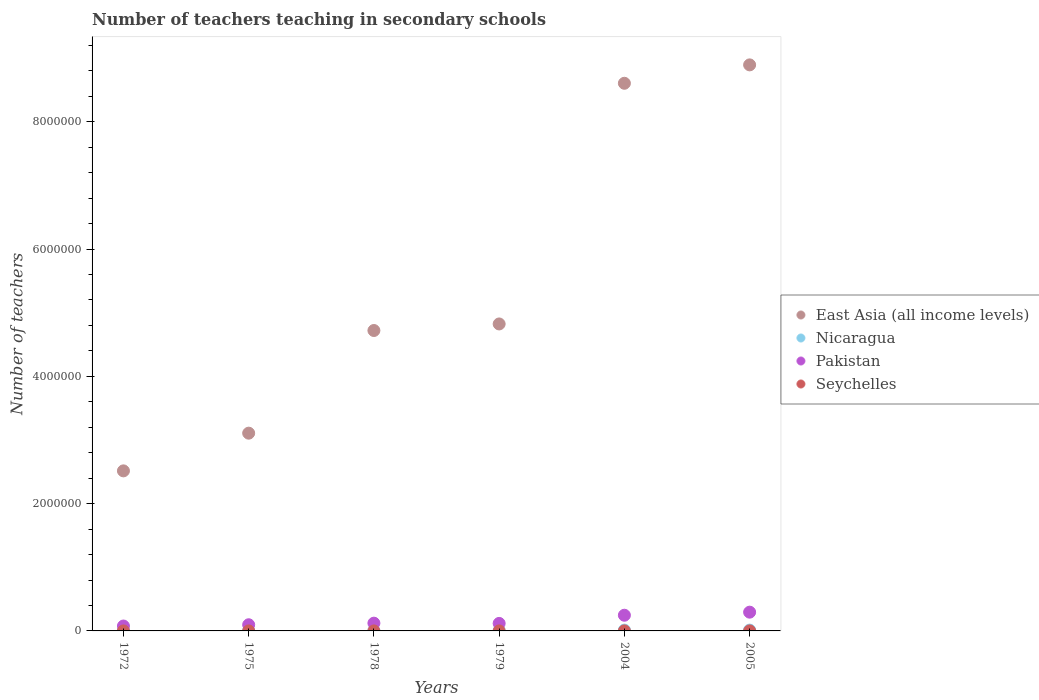How many different coloured dotlines are there?
Your response must be concise. 4. What is the number of teachers teaching in secondary schools in Seychelles in 1975?
Your answer should be compact. 177. Across all years, what is the maximum number of teachers teaching in secondary schools in East Asia (all income levels)?
Your answer should be compact. 8.89e+06. Across all years, what is the minimum number of teachers teaching in secondary schools in Seychelles?
Your answer should be very brief. 140. In which year was the number of teachers teaching in secondary schools in Nicaragua maximum?
Make the answer very short. 2005. In which year was the number of teachers teaching in secondary schools in Seychelles minimum?
Give a very brief answer. 1972. What is the total number of teachers teaching in secondary schools in East Asia (all income levels) in the graph?
Offer a terse response. 3.27e+07. What is the difference between the number of teachers teaching in secondary schools in East Asia (all income levels) in 1972 and that in 1978?
Your answer should be compact. -2.21e+06. What is the difference between the number of teachers teaching in secondary schools in Nicaragua in 1979 and the number of teachers teaching in secondary schools in East Asia (all income levels) in 1972?
Make the answer very short. -2.51e+06. What is the average number of teachers teaching in secondary schools in Nicaragua per year?
Provide a succinct answer. 6049.83. In the year 1978, what is the difference between the number of teachers teaching in secondary schools in Nicaragua and number of teachers teaching in secondary schools in Pakistan?
Offer a very short reply. -1.19e+05. In how many years, is the number of teachers teaching in secondary schools in Seychelles greater than 7200000?
Your answer should be very brief. 0. What is the ratio of the number of teachers teaching in secondary schools in Nicaragua in 1979 to that in 2004?
Provide a succinct answer. 0.28. Is the difference between the number of teachers teaching in secondary schools in Nicaragua in 1975 and 2005 greater than the difference between the number of teachers teaching in secondary schools in Pakistan in 1975 and 2005?
Your answer should be compact. Yes. What is the difference between the highest and the second highest number of teachers teaching in secondary schools in Pakistan?
Offer a terse response. 4.81e+04. What is the difference between the highest and the lowest number of teachers teaching in secondary schools in Nicaragua?
Make the answer very short. 1.11e+04. In how many years, is the number of teachers teaching in secondary schools in Pakistan greater than the average number of teachers teaching in secondary schools in Pakistan taken over all years?
Your answer should be compact. 2. Is the sum of the number of teachers teaching in secondary schools in Pakistan in 1975 and 2005 greater than the maximum number of teachers teaching in secondary schools in Seychelles across all years?
Keep it short and to the point. Yes. Is it the case that in every year, the sum of the number of teachers teaching in secondary schools in Nicaragua and number of teachers teaching in secondary schools in East Asia (all income levels)  is greater than the sum of number of teachers teaching in secondary schools in Pakistan and number of teachers teaching in secondary schools in Seychelles?
Ensure brevity in your answer.  Yes. How many years are there in the graph?
Offer a terse response. 6. What is the difference between two consecutive major ticks on the Y-axis?
Give a very brief answer. 2.00e+06. Are the values on the major ticks of Y-axis written in scientific E-notation?
Your answer should be compact. No. Does the graph contain any zero values?
Your answer should be compact. No. Where does the legend appear in the graph?
Offer a very short reply. Center right. How many legend labels are there?
Provide a short and direct response. 4. How are the legend labels stacked?
Give a very brief answer. Vertical. What is the title of the graph?
Your answer should be compact. Number of teachers teaching in secondary schools. What is the label or title of the Y-axis?
Offer a very short reply. Number of teachers. What is the Number of teachers in East Asia (all income levels) in 1972?
Provide a succinct answer. 2.52e+06. What is the Number of teachers of Nicaragua in 1972?
Give a very brief answer. 1916. What is the Number of teachers in Pakistan in 1972?
Keep it short and to the point. 7.69e+04. What is the Number of teachers in Seychelles in 1972?
Offer a very short reply. 140. What is the Number of teachers in East Asia (all income levels) in 1975?
Your answer should be very brief. 3.11e+06. What is the Number of teachers in Nicaragua in 1975?
Your answer should be very brief. 2308. What is the Number of teachers of Pakistan in 1975?
Your answer should be compact. 9.69e+04. What is the Number of teachers in Seychelles in 1975?
Your answer should be compact. 177. What is the Number of teachers of East Asia (all income levels) in 1978?
Provide a succinct answer. 4.72e+06. What is the Number of teachers of Nicaragua in 1978?
Ensure brevity in your answer.  2720. What is the Number of teachers in Pakistan in 1978?
Provide a succinct answer. 1.22e+05. What is the Number of teachers in Seychelles in 1978?
Keep it short and to the point. 242. What is the Number of teachers of East Asia (all income levels) in 1979?
Offer a terse response. 4.82e+06. What is the Number of teachers of Nicaragua in 1979?
Your answer should be compact. 3532. What is the Number of teachers of Pakistan in 1979?
Give a very brief answer. 1.18e+05. What is the Number of teachers of Seychelles in 1979?
Your answer should be very brief. 288. What is the Number of teachers of East Asia (all income levels) in 2004?
Your answer should be compact. 8.61e+06. What is the Number of teachers in Nicaragua in 2004?
Your answer should be very brief. 1.28e+04. What is the Number of teachers in Pakistan in 2004?
Make the answer very short. 2.47e+05. What is the Number of teachers of Seychelles in 2004?
Your response must be concise. 590. What is the Number of teachers of East Asia (all income levels) in 2005?
Provide a succinct answer. 8.89e+06. What is the Number of teachers of Nicaragua in 2005?
Make the answer very short. 1.30e+04. What is the Number of teachers of Pakistan in 2005?
Offer a very short reply. 2.95e+05. What is the Number of teachers in Seychelles in 2005?
Keep it short and to the point. 589. Across all years, what is the maximum Number of teachers of East Asia (all income levels)?
Offer a very short reply. 8.89e+06. Across all years, what is the maximum Number of teachers in Nicaragua?
Provide a short and direct response. 1.30e+04. Across all years, what is the maximum Number of teachers of Pakistan?
Keep it short and to the point. 2.95e+05. Across all years, what is the maximum Number of teachers in Seychelles?
Give a very brief answer. 590. Across all years, what is the minimum Number of teachers in East Asia (all income levels)?
Offer a very short reply. 2.52e+06. Across all years, what is the minimum Number of teachers of Nicaragua?
Ensure brevity in your answer.  1916. Across all years, what is the minimum Number of teachers in Pakistan?
Your answer should be very brief. 7.69e+04. Across all years, what is the minimum Number of teachers of Seychelles?
Your answer should be compact. 140. What is the total Number of teachers of East Asia (all income levels) in the graph?
Give a very brief answer. 3.27e+07. What is the total Number of teachers in Nicaragua in the graph?
Your response must be concise. 3.63e+04. What is the total Number of teachers in Pakistan in the graph?
Offer a very short reply. 9.55e+05. What is the total Number of teachers in Seychelles in the graph?
Your answer should be compact. 2026. What is the difference between the Number of teachers of East Asia (all income levels) in 1972 and that in 1975?
Provide a short and direct response. -5.92e+05. What is the difference between the Number of teachers of Nicaragua in 1972 and that in 1975?
Your answer should be very brief. -392. What is the difference between the Number of teachers in Pakistan in 1972 and that in 1975?
Provide a succinct answer. -2.00e+04. What is the difference between the Number of teachers of Seychelles in 1972 and that in 1975?
Offer a very short reply. -37. What is the difference between the Number of teachers of East Asia (all income levels) in 1972 and that in 1978?
Keep it short and to the point. -2.21e+06. What is the difference between the Number of teachers of Nicaragua in 1972 and that in 1978?
Keep it short and to the point. -804. What is the difference between the Number of teachers in Pakistan in 1972 and that in 1978?
Provide a short and direct response. -4.51e+04. What is the difference between the Number of teachers of Seychelles in 1972 and that in 1978?
Give a very brief answer. -102. What is the difference between the Number of teachers of East Asia (all income levels) in 1972 and that in 1979?
Your answer should be very brief. -2.31e+06. What is the difference between the Number of teachers in Nicaragua in 1972 and that in 1979?
Provide a succinct answer. -1616. What is the difference between the Number of teachers of Pakistan in 1972 and that in 1979?
Provide a short and direct response. -4.12e+04. What is the difference between the Number of teachers in Seychelles in 1972 and that in 1979?
Offer a terse response. -148. What is the difference between the Number of teachers in East Asia (all income levels) in 1972 and that in 2004?
Your response must be concise. -6.09e+06. What is the difference between the Number of teachers of Nicaragua in 1972 and that in 2004?
Keep it short and to the point. -1.09e+04. What is the difference between the Number of teachers in Pakistan in 1972 and that in 2004?
Provide a succinct answer. -1.70e+05. What is the difference between the Number of teachers in Seychelles in 1972 and that in 2004?
Give a very brief answer. -450. What is the difference between the Number of teachers in East Asia (all income levels) in 1972 and that in 2005?
Provide a short and direct response. -6.38e+06. What is the difference between the Number of teachers in Nicaragua in 1972 and that in 2005?
Give a very brief answer. -1.11e+04. What is the difference between the Number of teachers in Pakistan in 1972 and that in 2005?
Make the answer very short. -2.18e+05. What is the difference between the Number of teachers of Seychelles in 1972 and that in 2005?
Give a very brief answer. -449. What is the difference between the Number of teachers of East Asia (all income levels) in 1975 and that in 1978?
Keep it short and to the point. -1.61e+06. What is the difference between the Number of teachers in Nicaragua in 1975 and that in 1978?
Give a very brief answer. -412. What is the difference between the Number of teachers of Pakistan in 1975 and that in 1978?
Your answer should be compact. -2.50e+04. What is the difference between the Number of teachers of Seychelles in 1975 and that in 1978?
Provide a succinct answer. -65. What is the difference between the Number of teachers in East Asia (all income levels) in 1975 and that in 1979?
Your response must be concise. -1.72e+06. What is the difference between the Number of teachers in Nicaragua in 1975 and that in 1979?
Offer a very short reply. -1224. What is the difference between the Number of teachers in Pakistan in 1975 and that in 1979?
Your response must be concise. -2.11e+04. What is the difference between the Number of teachers of Seychelles in 1975 and that in 1979?
Ensure brevity in your answer.  -111. What is the difference between the Number of teachers of East Asia (all income levels) in 1975 and that in 2004?
Offer a terse response. -5.50e+06. What is the difference between the Number of teachers in Nicaragua in 1975 and that in 2004?
Offer a terse response. -1.05e+04. What is the difference between the Number of teachers in Pakistan in 1975 and that in 2004?
Offer a very short reply. -1.50e+05. What is the difference between the Number of teachers of Seychelles in 1975 and that in 2004?
Provide a short and direct response. -413. What is the difference between the Number of teachers in East Asia (all income levels) in 1975 and that in 2005?
Your answer should be compact. -5.79e+06. What is the difference between the Number of teachers in Nicaragua in 1975 and that in 2005?
Your answer should be very brief. -1.07e+04. What is the difference between the Number of teachers of Pakistan in 1975 and that in 2005?
Your answer should be compact. -1.98e+05. What is the difference between the Number of teachers of Seychelles in 1975 and that in 2005?
Keep it short and to the point. -412. What is the difference between the Number of teachers in East Asia (all income levels) in 1978 and that in 1979?
Offer a terse response. -1.03e+05. What is the difference between the Number of teachers in Nicaragua in 1978 and that in 1979?
Offer a very short reply. -812. What is the difference between the Number of teachers in Pakistan in 1978 and that in 1979?
Offer a terse response. 3885. What is the difference between the Number of teachers in Seychelles in 1978 and that in 1979?
Offer a very short reply. -46. What is the difference between the Number of teachers of East Asia (all income levels) in 1978 and that in 2004?
Offer a very short reply. -3.88e+06. What is the difference between the Number of teachers of Nicaragua in 1978 and that in 2004?
Your answer should be very brief. -1.01e+04. What is the difference between the Number of teachers of Pakistan in 1978 and that in 2004?
Your response must be concise. -1.25e+05. What is the difference between the Number of teachers in Seychelles in 1978 and that in 2004?
Keep it short and to the point. -348. What is the difference between the Number of teachers in East Asia (all income levels) in 1978 and that in 2005?
Make the answer very short. -4.17e+06. What is the difference between the Number of teachers in Nicaragua in 1978 and that in 2005?
Offer a terse response. -1.03e+04. What is the difference between the Number of teachers of Pakistan in 1978 and that in 2005?
Make the answer very short. -1.73e+05. What is the difference between the Number of teachers in Seychelles in 1978 and that in 2005?
Give a very brief answer. -347. What is the difference between the Number of teachers in East Asia (all income levels) in 1979 and that in 2004?
Your response must be concise. -3.78e+06. What is the difference between the Number of teachers of Nicaragua in 1979 and that in 2004?
Your answer should be compact. -9311. What is the difference between the Number of teachers in Pakistan in 1979 and that in 2004?
Your response must be concise. -1.28e+05. What is the difference between the Number of teachers in Seychelles in 1979 and that in 2004?
Offer a very short reply. -302. What is the difference between the Number of teachers of East Asia (all income levels) in 1979 and that in 2005?
Give a very brief answer. -4.07e+06. What is the difference between the Number of teachers in Nicaragua in 1979 and that in 2005?
Provide a succinct answer. -9448. What is the difference between the Number of teachers in Pakistan in 1979 and that in 2005?
Keep it short and to the point. -1.77e+05. What is the difference between the Number of teachers in Seychelles in 1979 and that in 2005?
Give a very brief answer. -301. What is the difference between the Number of teachers in East Asia (all income levels) in 2004 and that in 2005?
Provide a short and direct response. -2.89e+05. What is the difference between the Number of teachers of Nicaragua in 2004 and that in 2005?
Your answer should be compact. -137. What is the difference between the Number of teachers of Pakistan in 2004 and that in 2005?
Your response must be concise. -4.81e+04. What is the difference between the Number of teachers of Seychelles in 2004 and that in 2005?
Offer a terse response. 1. What is the difference between the Number of teachers in East Asia (all income levels) in 1972 and the Number of teachers in Nicaragua in 1975?
Provide a short and direct response. 2.51e+06. What is the difference between the Number of teachers in East Asia (all income levels) in 1972 and the Number of teachers in Pakistan in 1975?
Ensure brevity in your answer.  2.42e+06. What is the difference between the Number of teachers of East Asia (all income levels) in 1972 and the Number of teachers of Seychelles in 1975?
Your answer should be compact. 2.51e+06. What is the difference between the Number of teachers of Nicaragua in 1972 and the Number of teachers of Pakistan in 1975?
Offer a very short reply. -9.50e+04. What is the difference between the Number of teachers of Nicaragua in 1972 and the Number of teachers of Seychelles in 1975?
Offer a terse response. 1739. What is the difference between the Number of teachers in Pakistan in 1972 and the Number of teachers in Seychelles in 1975?
Your answer should be very brief. 7.67e+04. What is the difference between the Number of teachers of East Asia (all income levels) in 1972 and the Number of teachers of Nicaragua in 1978?
Your answer should be compact. 2.51e+06. What is the difference between the Number of teachers of East Asia (all income levels) in 1972 and the Number of teachers of Pakistan in 1978?
Provide a short and direct response. 2.39e+06. What is the difference between the Number of teachers of East Asia (all income levels) in 1972 and the Number of teachers of Seychelles in 1978?
Provide a succinct answer. 2.51e+06. What is the difference between the Number of teachers in Nicaragua in 1972 and the Number of teachers in Pakistan in 1978?
Offer a terse response. -1.20e+05. What is the difference between the Number of teachers of Nicaragua in 1972 and the Number of teachers of Seychelles in 1978?
Provide a succinct answer. 1674. What is the difference between the Number of teachers in Pakistan in 1972 and the Number of teachers in Seychelles in 1978?
Keep it short and to the point. 7.67e+04. What is the difference between the Number of teachers in East Asia (all income levels) in 1972 and the Number of teachers in Nicaragua in 1979?
Make the answer very short. 2.51e+06. What is the difference between the Number of teachers in East Asia (all income levels) in 1972 and the Number of teachers in Pakistan in 1979?
Ensure brevity in your answer.  2.40e+06. What is the difference between the Number of teachers of East Asia (all income levels) in 1972 and the Number of teachers of Seychelles in 1979?
Make the answer very short. 2.51e+06. What is the difference between the Number of teachers in Nicaragua in 1972 and the Number of teachers in Pakistan in 1979?
Your answer should be very brief. -1.16e+05. What is the difference between the Number of teachers of Nicaragua in 1972 and the Number of teachers of Seychelles in 1979?
Offer a very short reply. 1628. What is the difference between the Number of teachers in Pakistan in 1972 and the Number of teachers in Seychelles in 1979?
Provide a succinct answer. 7.66e+04. What is the difference between the Number of teachers of East Asia (all income levels) in 1972 and the Number of teachers of Nicaragua in 2004?
Your answer should be compact. 2.50e+06. What is the difference between the Number of teachers of East Asia (all income levels) in 1972 and the Number of teachers of Pakistan in 2004?
Your response must be concise. 2.27e+06. What is the difference between the Number of teachers in East Asia (all income levels) in 1972 and the Number of teachers in Seychelles in 2004?
Make the answer very short. 2.51e+06. What is the difference between the Number of teachers in Nicaragua in 1972 and the Number of teachers in Pakistan in 2004?
Offer a terse response. -2.45e+05. What is the difference between the Number of teachers of Nicaragua in 1972 and the Number of teachers of Seychelles in 2004?
Offer a very short reply. 1326. What is the difference between the Number of teachers of Pakistan in 1972 and the Number of teachers of Seychelles in 2004?
Your response must be concise. 7.63e+04. What is the difference between the Number of teachers of East Asia (all income levels) in 1972 and the Number of teachers of Nicaragua in 2005?
Provide a short and direct response. 2.50e+06. What is the difference between the Number of teachers in East Asia (all income levels) in 1972 and the Number of teachers in Pakistan in 2005?
Offer a terse response. 2.22e+06. What is the difference between the Number of teachers of East Asia (all income levels) in 1972 and the Number of teachers of Seychelles in 2005?
Your answer should be very brief. 2.51e+06. What is the difference between the Number of teachers in Nicaragua in 1972 and the Number of teachers in Pakistan in 2005?
Keep it short and to the point. -2.93e+05. What is the difference between the Number of teachers of Nicaragua in 1972 and the Number of teachers of Seychelles in 2005?
Your answer should be compact. 1327. What is the difference between the Number of teachers of Pakistan in 1972 and the Number of teachers of Seychelles in 2005?
Provide a short and direct response. 7.63e+04. What is the difference between the Number of teachers in East Asia (all income levels) in 1975 and the Number of teachers in Nicaragua in 1978?
Offer a very short reply. 3.10e+06. What is the difference between the Number of teachers of East Asia (all income levels) in 1975 and the Number of teachers of Pakistan in 1978?
Provide a short and direct response. 2.99e+06. What is the difference between the Number of teachers in East Asia (all income levels) in 1975 and the Number of teachers in Seychelles in 1978?
Give a very brief answer. 3.11e+06. What is the difference between the Number of teachers in Nicaragua in 1975 and the Number of teachers in Pakistan in 1978?
Offer a very short reply. -1.20e+05. What is the difference between the Number of teachers of Nicaragua in 1975 and the Number of teachers of Seychelles in 1978?
Your response must be concise. 2066. What is the difference between the Number of teachers of Pakistan in 1975 and the Number of teachers of Seychelles in 1978?
Keep it short and to the point. 9.67e+04. What is the difference between the Number of teachers of East Asia (all income levels) in 1975 and the Number of teachers of Nicaragua in 1979?
Offer a very short reply. 3.10e+06. What is the difference between the Number of teachers of East Asia (all income levels) in 1975 and the Number of teachers of Pakistan in 1979?
Offer a very short reply. 2.99e+06. What is the difference between the Number of teachers of East Asia (all income levels) in 1975 and the Number of teachers of Seychelles in 1979?
Your answer should be compact. 3.11e+06. What is the difference between the Number of teachers in Nicaragua in 1975 and the Number of teachers in Pakistan in 1979?
Ensure brevity in your answer.  -1.16e+05. What is the difference between the Number of teachers in Nicaragua in 1975 and the Number of teachers in Seychelles in 1979?
Offer a very short reply. 2020. What is the difference between the Number of teachers of Pakistan in 1975 and the Number of teachers of Seychelles in 1979?
Provide a succinct answer. 9.67e+04. What is the difference between the Number of teachers in East Asia (all income levels) in 1975 and the Number of teachers in Nicaragua in 2004?
Keep it short and to the point. 3.09e+06. What is the difference between the Number of teachers in East Asia (all income levels) in 1975 and the Number of teachers in Pakistan in 2004?
Give a very brief answer. 2.86e+06. What is the difference between the Number of teachers in East Asia (all income levels) in 1975 and the Number of teachers in Seychelles in 2004?
Make the answer very short. 3.11e+06. What is the difference between the Number of teachers in Nicaragua in 1975 and the Number of teachers in Pakistan in 2004?
Provide a short and direct response. -2.44e+05. What is the difference between the Number of teachers in Nicaragua in 1975 and the Number of teachers in Seychelles in 2004?
Make the answer very short. 1718. What is the difference between the Number of teachers in Pakistan in 1975 and the Number of teachers in Seychelles in 2004?
Ensure brevity in your answer.  9.64e+04. What is the difference between the Number of teachers in East Asia (all income levels) in 1975 and the Number of teachers in Nicaragua in 2005?
Provide a succinct answer. 3.09e+06. What is the difference between the Number of teachers of East Asia (all income levels) in 1975 and the Number of teachers of Pakistan in 2005?
Offer a terse response. 2.81e+06. What is the difference between the Number of teachers in East Asia (all income levels) in 1975 and the Number of teachers in Seychelles in 2005?
Your answer should be compact. 3.11e+06. What is the difference between the Number of teachers of Nicaragua in 1975 and the Number of teachers of Pakistan in 2005?
Give a very brief answer. -2.92e+05. What is the difference between the Number of teachers of Nicaragua in 1975 and the Number of teachers of Seychelles in 2005?
Make the answer very short. 1719. What is the difference between the Number of teachers of Pakistan in 1975 and the Number of teachers of Seychelles in 2005?
Ensure brevity in your answer.  9.64e+04. What is the difference between the Number of teachers in East Asia (all income levels) in 1978 and the Number of teachers in Nicaragua in 1979?
Offer a very short reply. 4.72e+06. What is the difference between the Number of teachers in East Asia (all income levels) in 1978 and the Number of teachers in Pakistan in 1979?
Your answer should be compact. 4.60e+06. What is the difference between the Number of teachers in East Asia (all income levels) in 1978 and the Number of teachers in Seychelles in 1979?
Provide a succinct answer. 4.72e+06. What is the difference between the Number of teachers in Nicaragua in 1978 and the Number of teachers in Pakistan in 1979?
Give a very brief answer. -1.15e+05. What is the difference between the Number of teachers of Nicaragua in 1978 and the Number of teachers of Seychelles in 1979?
Provide a short and direct response. 2432. What is the difference between the Number of teachers of Pakistan in 1978 and the Number of teachers of Seychelles in 1979?
Provide a short and direct response. 1.22e+05. What is the difference between the Number of teachers in East Asia (all income levels) in 1978 and the Number of teachers in Nicaragua in 2004?
Make the answer very short. 4.71e+06. What is the difference between the Number of teachers in East Asia (all income levels) in 1978 and the Number of teachers in Pakistan in 2004?
Offer a terse response. 4.47e+06. What is the difference between the Number of teachers in East Asia (all income levels) in 1978 and the Number of teachers in Seychelles in 2004?
Make the answer very short. 4.72e+06. What is the difference between the Number of teachers in Nicaragua in 1978 and the Number of teachers in Pakistan in 2004?
Provide a short and direct response. -2.44e+05. What is the difference between the Number of teachers of Nicaragua in 1978 and the Number of teachers of Seychelles in 2004?
Ensure brevity in your answer.  2130. What is the difference between the Number of teachers in Pakistan in 1978 and the Number of teachers in Seychelles in 2004?
Make the answer very short. 1.21e+05. What is the difference between the Number of teachers of East Asia (all income levels) in 1978 and the Number of teachers of Nicaragua in 2005?
Your answer should be very brief. 4.71e+06. What is the difference between the Number of teachers in East Asia (all income levels) in 1978 and the Number of teachers in Pakistan in 2005?
Your answer should be very brief. 4.43e+06. What is the difference between the Number of teachers of East Asia (all income levels) in 1978 and the Number of teachers of Seychelles in 2005?
Offer a terse response. 4.72e+06. What is the difference between the Number of teachers in Nicaragua in 1978 and the Number of teachers in Pakistan in 2005?
Offer a terse response. -2.92e+05. What is the difference between the Number of teachers in Nicaragua in 1978 and the Number of teachers in Seychelles in 2005?
Make the answer very short. 2131. What is the difference between the Number of teachers in Pakistan in 1978 and the Number of teachers in Seychelles in 2005?
Provide a short and direct response. 1.21e+05. What is the difference between the Number of teachers in East Asia (all income levels) in 1979 and the Number of teachers in Nicaragua in 2004?
Ensure brevity in your answer.  4.81e+06. What is the difference between the Number of teachers in East Asia (all income levels) in 1979 and the Number of teachers in Pakistan in 2004?
Ensure brevity in your answer.  4.58e+06. What is the difference between the Number of teachers in East Asia (all income levels) in 1979 and the Number of teachers in Seychelles in 2004?
Ensure brevity in your answer.  4.82e+06. What is the difference between the Number of teachers of Nicaragua in 1979 and the Number of teachers of Pakistan in 2004?
Give a very brief answer. -2.43e+05. What is the difference between the Number of teachers in Nicaragua in 1979 and the Number of teachers in Seychelles in 2004?
Ensure brevity in your answer.  2942. What is the difference between the Number of teachers of Pakistan in 1979 and the Number of teachers of Seychelles in 2004?
Provide a succinct answer. 1.17e+05. What is the difference between the Number of teachers of East Asia (all income levels) in 1979 and the Number of teachers of Nicaragua in 2005?
Offer a very short reply. 4.81e+06. What is the difference between the Number of teachers in East Asia (all income levels) in 1979 and the Number of teachers in Pakistan in 2005?
Keep it short and to the point. 4.53e+06. What is the difference between the Number of teachers of East Asia (all income levels) in 1979 and the Number of teachers of Seychelles in 2005?
Your response must be concise. 4.82e+06. What is the difference between the Number of teachers of Nicaragua in 1979 and the Number of teachers of Pakistan in 2005?
Your answer should be very brief. -2.91e+05. What is the difference between the Number of teachers in Nicaragua in 1979 and the Number of teachers in Seychelles in 2005?
Keep it short and to the point. 2943. What is the difference between the Number of teachers in Pakistan in 1979 and the Number of teachers in Seychelles in 2005?
Offer a terse response. 1.17e+05. What is the difference between the Number of teachers of East Asia (all income levels) in 2004 and the Number of teachers of Nicaragua in 2005?
Your answer should be very brief. 8.59e+06. What is the difference between the Number of teachers in East Asia (all income levels) in 2004 and the Number of teachers in Pakistan in 2005?
Offer a very short reply. 8.31e+06. What is the difference between the Number of teachers of East Asia (all income levels) in 2004 and the Number of teachers of Seychelles in 2005?
Provide a short and direct response. 8.60e+06. What is the difference between the Number of teachers in Nicaragua in 2004 and the Number of teachers in Pakistan in 2005?
Your response must be concise. -2.82e+05. What is the difference between the Number of teachers in Nicaragua in 2004 and the Number of teachers in Seychelles in 2005?
Provide a short and direct response. 1.23e+04. What is the difference between the Number of teachers of Pakistan in 2004 and the Number of teachers of Seychelles in 2005?
Keep it short and to the point. 2.46e+05. What is the average Number of teachers of East Asia (all income levels) per year?
Offer a very short reply. 5.44e+06. What is the average Number of teachers in Nicaragua per year?
Give a very brief answer. 6049.83. What is the average Number of teachers of Pakistan per year?
Offer a terse response. 1.59e+05. What is the average Number of teachers in Seychelles per year?
Provide a succinct answer. 337.67. In the year 1972, what is the difference between the Number of teachers of East Asia (all income levels) and Number of teachers of Nicaragua?
Keep it short and to the point. 2.51e+06. In the year 1972, what is the difference between the Number of teachers in East Asia (all income levels) and Number of teachers in Pakistan?
Offer a very short reply. 2.44e+06. In the year 1972, what is the difference between the Number of teachers in East Asia (all income levels) and Number of teachers in Seychelles?
Provide a succinct answer. 2.51e+06. In the year 1972, what is the difference between the Number of teachers of Nicaragua and Number of teachers of Pakistan?
Offer a terse response. -7.50e+04. In the year 1972, what is the difference between the Number of teachers in Nicaragua and Number of teachers in Seychelles?
Provide a short and direct response. 1776. In the year 1972, what is the difference between the Number of teachers of Pakistan and Number of teachers of Seychelles?
Give a very brief answer. 7.68e+04. In the year 1975, what is the difference between the Number of teachers in East Asia (all income levels) and Number of teachers in Nicaragua?
Ensure brevity in your answer.  3.11e+06. In the year 1975, what is the difference between the Number of teachers of East Asia (all income levels) and Number of teachers of Pakistan?
Ensure brevity in your answer.  3.01e+06. In the year 1975, what is the difference between the Number of teachers in East Asia (all income levels) and Number of teachers in Seychelles?
Give a very brief answer. 3.11e+06. In the year 1975, what is the difference between the Number of teachers in Nicaragua and Number of teachers in Pakistan?
Offer a very short reply. -9.46e+04. In the year 1975, what is the difference between the Number of teachers in Nicaragua and Number of teachers in Seychelles?
Your answer should be compact. 2131. In the year 1975, what is the difference between the Number of teachers of Pakistan and Number of teachers of Seychelles?
Make the answer very short. 9.68e+04. In the year 1978, what is the difference between the Number of teachers of East Asia (all income levels) and Number of teachers of Nicaragua?
Keep it short and to the point. 4.72e+06. In the year 1978, what is the difference between the Number of teachers in East Asia (all income levels) and Number of teachers in Pakistan?
Give a very brief answer. 4.60e+06. In the year 1978, what is the difference between the Number of teachers in East Asia (all income levels) and Number of teachers in Seychelles?
Offer a very short reply. 4.72e+06. In the year 1978, what is the difference between the Number of teachers in Nicaragua and Number of teachers in Pakistan?
Your answer should be compact. -1.19e+05. In the year 1978, what is the difference between the Number of teachers of Nicaragua and Number of teachers of Seychelles?
Offer a terse response. 2478. In the year 1978, what is the difference between the Number of teachers in Pakistan and Number of teachers in Seychelles?
Keep it short and to the point. 1.22e+05. In the year 1979, what is the difference between the Number of teachers in East Asia (all income levels) and Number of teachers in Nicaragua?
Offer a very short reply. 4.82e+06. In the year 1979, what is the difference between the Number of teachers of East Asia (all income levels) and Number of teachers of Pakistan?
Offer a very short reply. 4.71e+06. In the year 1979, what is the difference between the Number of teachers of East Asia (all income levels) and Number of teachers of Seychelles?
Offer a very short reply. 4.82e+06. In the year 1979, what is the difference between the Number of teachers in Nicaragua and Number of teachers in Pakistan?
Make the answer very short. -1.15e+05. In the year 1979, what is the difference between the Number of teachers of Nicaragua and Number of teachers of Seychelles?
Offer a very short reply. 3244. In the year 1979, what is the difference between the Number of teachers in Pakistan and Number of teachers in Seychelles?
Your answer should be very brief. 1.18e+05. In the year 2004, what is the difference between the Number of teachers of East Asia (all income levels) and Number of teachers of Nicaragua?
Provide a short and direct response. 8.59e+06. In the year 2004, what is the difference between the Number of teachers in East Asia (all income levels) and Number of teachers in Pakistan?
Ensure brevity in your answer.  8.36e+06. In the year 2004, what is the difference between the Number of teachers of East Asia (all income levels) and Number of teachers of Seychelles?
Provide a succinct answer. 8.60e+06. In the year 2004, what is the difference between the Number of teachers in Nicaragua and Number of teachers in Pakistan?
Keep it short and to the point. -2.34e+05. In the year 2004, what is the difference between the Number of teachers in Nicaragua and Number of teachers in Seychelles?
Your answer should be compact. 1.23e+04. In the year 2004, what is the difference between the Number of teachers of Pakistan and Number of teachers of Seychelles?
Your answer should be compact. 2.46e+05. In the year 2005, what is the difference between the Number of teachers in East Asia (all income levels) and Number of teachers in Nicaragua?
Make the answer very short. 8.88e+06. In the year 2005, what is the difference between the Number of teachers of East Asia (all income levels) and Number of teachers of Pakistan?
Ensure brevity in your answer.  8.60e+06. In the year 2005, what is the difference between the Number of teachers of East Asia (all income levels) and Number of teachers of Seychelles?
Your response must be concise. 8.89e+06. In the year 2005, what is the difference between the Number of teachers in Nicaragua and Number of teachers in Pakistan?
Make the answer very short. -2.82e+05. In the year 2005, what is the difference between the Number of teachers of Nicaragua and Number of teachers of Seychelles?
Offer a terse response. 1.24e+04. In the year 2005, what is the difference between the Number of teachers in Pakistan and Number of teachers in Seychelles?
Provide a short and direct response. 2.94e+05. What is the ratio of the Number of teachers of East Asia (all income levels) in 1972 to that in 1975?
Provide a succinct answer. 0.81. What is the ratio of the Number of teachers of Nicaragua in 1972 to that in 1975?
Keep it short and to the point. 0.83. What is the ratio of the Number of teachers in Pakistan in 1972 to that in 1975?
Your answer should be very brief. 0.79. What is the ratio of the Number of teachers of Seychelles in 1972 to that in 1975?
Offer a very short reply. 0.79. What is the ratio of the Number of teachers of East Asia (all income levels) in 1972 to that in 1978?
Make the answer very short. 0.53. What is the ratio of the Number of teachers in Nicaragua in 1972 to that in 1978?
Give a very brief answer. 0.7. What is the ratio of the Number of teachers of Pakistan in 1972 to that in 1978?
Make the answer very short. 0.63. What is the ratio of the Number of teachers of Seychelles in 1972 to that in 1978?
Ensure brevity in your answer.  0.58. What is the ratio of the Number of teachers of East Asia (all income levels) in 1972 to that in 1979?
Your answer should be compact. 0.52. What is the ratio of the Number of teachers of Nicaragua in 1972 to that in 1979?
Make the answer very short. 0.54. What is the ratio of the Number of teachers of Pakistan in 1972 to that in 1979?
Your answer should be compact. 0.65. What is the ratio of the Number of teachers of Seychelles in 1972 to that in 1979?
Provide a short and direct response. 0.49. What is the ratio of the Number of teachers of East Asia (all income levels) in 1972 to that in 2004?
Provide a succinct answer. 0.29. What is the ratio of the Number of teachers of Nicaragua in 1972 to that in 2004?
Your answer should be compact. 0.15. What is the ratio of the Number of teachers in Pakistan in 1972 to that in 2004?
Give a very brief answer. 0.31. What is the ratio of the Number of teachers in Seychelles in 1972 to that in 2004?
Offer a terse response. 0.24. What is the ratio of the Number of teachers in East Asia (all income levels) in 1972 to that in 2005?
Your response must be concise. 0.28. What is the ratio of the Number of teachers in Nicaragua in 1972 to that in 2005?
Make the answer very short. 0.15. What is the ratio of the Number of teachers in Pakistan in 1972 to that in 2005?
Provide a succinct answer. 0.26. What is the ratio of the Number of teachers of Seychelles in 1972 to that in 2005?
Provide a short and direct response. 0.24. What is the ratio of the Number of teachers in East Asia (all income levels) in 1975 to that in 1978?
Offer a very short reply. 0.66. What is the ratio of the Number of teachers in Nicaragua in 1975 to that in 1978?
Make the answer very short. 0.85. What is the ratio of the Number of teachers in Pakistan in 1975 to that in 1978?
Keep it short and to the point. 0.79. What is the ratio of the Number of teachers in Seychelles in 1975 to that in 1978?
Offer a terse response. 0.73. What is the ratio of the Number of teachers in East Asia (all income levels) in 1975 to that in 1979?
Give a very brief answer. 0.64. What is the ratio of the Number of teachers in Nicaragua in 1975 to that in 1979?
Make the answer very short. 0.65. What is the ratio of the Number of teachers of Pakistan in 1975 to that in 1979?
Give a very brief answer. 0.82. What is the ratio of the Number of teachers of Seychelles in 1975 to that in 1979?
Your response must be concise. 0.61. What is the ratio of the Number of teachers of East Asia (all income levels) in 1975 to that in 2004?
Keep it short and to the point. 0.36. What is the ratio of the Number of teachers of Nicaragua in 1975 to that in 2004?
Your answer should be compact. 0.18. What is the ratio of the Number of teachers of Pakistan in 1975 to that in 2004?
Give a very brief answer. 0.39. What is the ratio of the Number of teachers in Seychelles in 1975 to that in 2004?
Provide a succinct answer. 0.3. What is the ratio of the Number of teachers of East Asia (all income levels) in 1975 to that in 2005?
Offer a terse response. 0.35. What is the ratio of the Number of teachers of Nicaragua in 1975 to that in 2005?
Ensure brevity in your answer.  0.18. What is the ratio of the Number of teachers of Pakistan in 1975 to that in 2005?
Provide a short and direct response. 0.33. What is the ratio of the Number of teachers in Seychelles in 1975 to that in 2005?
Your response must be concise. 0.3. What is the ratio of the Number of teachers of East Asia (all income levels) in 1978 to that in 1979?
Offer a very short reply. 0.98. What is the ratio of the Number of teachers of Nicaragua in 1978 to that in 1979?
Offer a very short reply. 0.77. What is the ratio of the Number of teachers of Pakistan in 1978 to that in 1979?
Provide a short and direct response. 1.03. What is the ratio of the Number of teachers of Seychelles in 1978 to that in 1979?
Your answer should be compact. 0.84. What is the ratio of the Number of teachers of East Asia (all income levels) in 1978 to that in 2004?
Offer a very short reply. 0.55. What is the ratio of the Number of teachers in Nicaragua in 1978 to that in 2004?
Give a very brief answer. 0.21. What is the ratio of the Number of teachers in Pakistan in 1978 to that in 2004?
Provide a succinct answer. 0.49. What is the ratio of the Number of teachers of Seychelles in 1978 to that in 2004?
Offer a terse response. 0.41. What is the ratio of the Number of teachers of East Asia (all income levels) in 1978 to that in 2005?
Ensure brevity in your answer.  0.53. What is the ratio of the Number of teachers in Nicaragua in 1978 to that in 2005?
Provide a short and direct response. 0.21. What is the ratio of the Number of teachers of Pakistan in 1978 to that in 2005?
Ensure brevity in your answer.  0.41. What is the ratio of the Number of teachers in Seychelles in 1978 to that in 2005?
Offer a terse response. 0.41. What is the ratio of the Number of teachers in East Asia (all income levels) in 1979 to that in 2004?
Provide a succinct answer. 0.56. What is the ratio of the Number of teachers in Nicaragua in 1979 to that in 2004?
Your answer should be compact. 0.28. What is the ratio of the Number of teachers in Pakistan in 1979 to that in 2004?
Keep it short and to the point. 0.48. What is the ratio of the Number of teachers in Seychelles in 1979 to that in 2004?
Ensure brevity in your answer.  0.49. What is the ratio of the Number of teachers in East Asia (all income levels) in 1979 to that in 2005?
Provide a succinct answer. 0.54. What is the ratio of the Number of teachers of Nicaragua in 1979 to that in 2005?
Your response must be concise. 0.27. What is the ratio of the Number of teachers of Pakistan in 1979 to that in 2005?
Your response must be concise. 0.4. What is the ratio of the Number of teachers of Seychelles in 1979 to that in 2005?
Provide a short and direct response. 0.49. What is the ratio of the Number of teachers in East Asia (all income levels) in 2004 to that in 2005?
Make the answer very short. 0.97. What is the ratio of the Number of teachers in Pakistan in 2004 to that in 2005?
Offer a terse response. 0.84. What is the ratio of the Number of teachers in Seychelles in 2004 to that in 2005?
Offer a very short reply. 1. What is the difference between the highest and the second highest Number of teachers in East Asia (all income levels)?
Keep it short and to the point. 2.89e+05. What is the difference between the highest and the second highest Number of teachers of Nicaragua?
Give a very brief answer. 137. What is the difference between the highest and the second highest Number of teachers of Pakistan?
Offer a terse response. 4.81e+04. What is the difference between the highest and the lowest Number of teachers in East Asia (all income levels)?
Your answer should be very brief. 6.38e+06. What is the difference between the highest and the lowest Number of teachers of Nicaragua?
Provide a succinct answer. 1.11e+04. What is the difference between the highest and the lowest Number of teachers in Pakistan?
Keep it short and to the point. 2.18e+05. What is the difference between the highest and the lowest Number of teachers of Seychelles?
Your response must be concise. 450. 